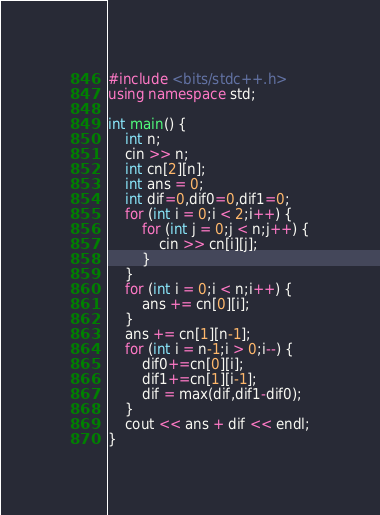Convert code to text. <code><loc_0><loc_0><loc_500><loc_500><_C++_>#include <bits/stdc++.h>
using namespace std;

int main() {
	int n;
	cin >> n;
	int cn[2][n];
	int ans = 0;
	int dif=0,dif0=0,dif1=0;
	for (int i = 0;i < 2;i++) {
		for (int j = 0;j < n;j++) {
			cin >> cn[i][j];
		}
	}
	for (int i = 0;i < n;i++) {
		ans += cn[0][i];
	}
	ans += cn[1][n-1];
	for (int i = n-1;i > 0;i--) {
		dif0+=cn[0][i];
		dif1+=cn[1][i-1];
		dif = max(dif,dif1-dif0);
	}
	cout << ans + dif << endl;
}</code> 